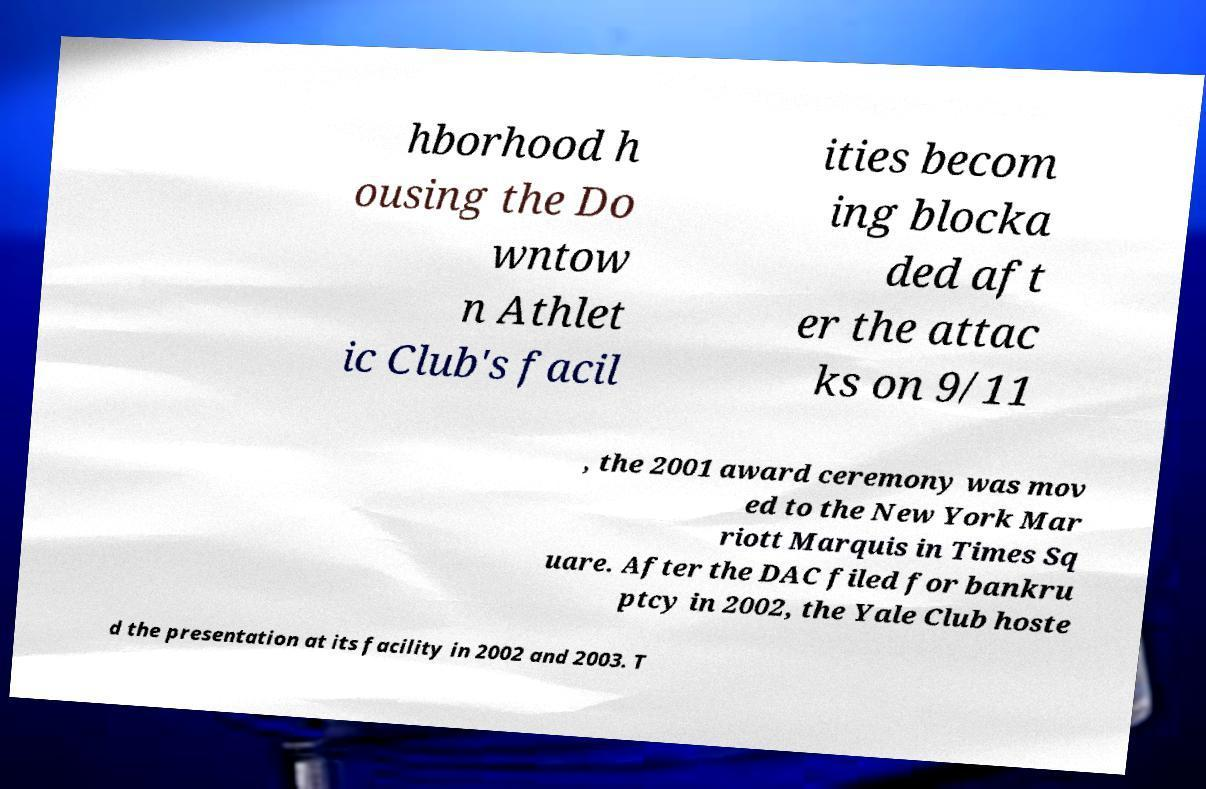Could you extract and type out the text from this image? hborhood h ousing the Do wntow n Athlet ic Club's facil ities becom ing blocka ded aft er the attac ks on 9/11 , the 2001 award ceremony was mov ed to the New York Mar riott Marquis in Times Sq uare. After the DAC filed for bankru ptcy in 2002, the Yale Club hoste d the presentation at its facility in 2002 and 2003. T 